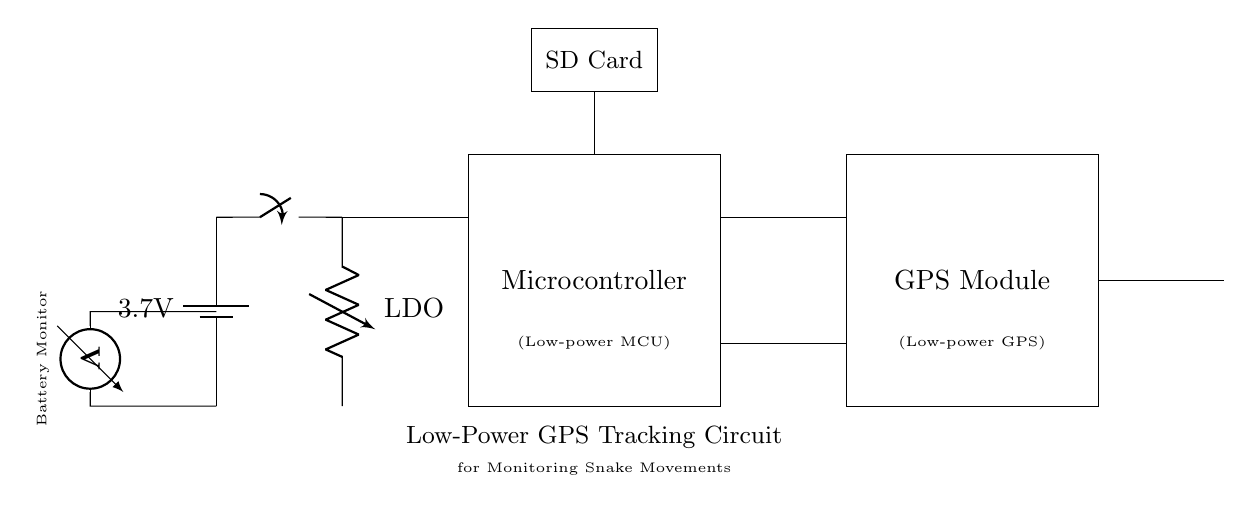What is the voltage of this circuit? The voltage is 3.7 volts, which is specified on the battery connected at the beginning of the circuit.
Answer: 3.7 volts What type of component is the item labeled "Microcontroller"? The Microcontroller is categorized as a low-power Microcontroller, as indicated in the label within the rectangle representing the component.
Answer: Low-power Microcontroller How is the GPS module powered? The GPS module is powered through the connections between the microcontroller and an LDO voltage regulator, which provides the required voltage from the battery.
Answer: Through LDO voltage regulator What is the function of the battery monitor? The battery monitor measures the voltage of the battery and is indicated by the voltmeter design in the circuit, allowing for monitoring of the battery's charge level.
Answer: Measures battery voltage Why is low-power design emphasized in this circuit? Low-power design is critical for maximizing battery life, especially in tracking devices used in wildlife studies, as they need to operate for extended periods in the field with limited power supply.
Answer: To maximize battery life What does the antenna in the circuit do? The antenna's role is to transmit the GPS signals collected by the GPS module, facilitating communication with satellite systems for tracking purposes.
Answer: Transmits GPS signals Which component is used to store data? The SD Card is used to store data collected by the microcontroller and GPS module, indicated by its labeled rectangle above the microcontroller.
Answer: SD Card 